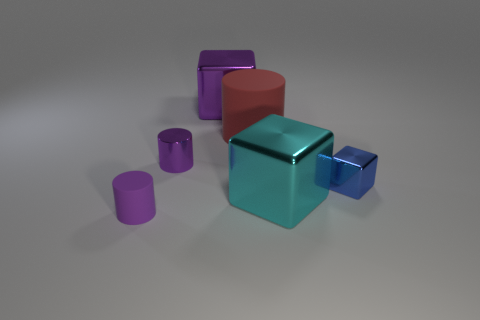There is a cyan metallic thing in front of the big object that is left of the matte cylinder that is on the right side of the big purple thing; what shape is it?
Keep it short and to the point. Cube. What material is the purple object that is both behind the cyan metal cube and in front of the big purple shiny object?
Keep it short and to the point. Metal. What number of purple cylinders are the same size as the blue object?
Keep it short and to the point. 2. What number of shiny things are either small red balls or cyan cubes?
Provide a short and direct response. 1. What is the large purple block made of?
Offer a terse response. Metal. What number of small purple objects are to the right of the red rubber thing?
Offer a terse response. 0. Is the material of the large block to the left of the large red rubber thing the same as the cyan object?
Your answer should be compact. Yes. What number of other purple shiny things are the same shape as the large purple object?
Ensure brevity in your answer.  0. What number of large objects are cubes or yellow cylinders?
Ensure brevity in your answer.  2. There is a big metallic object that is behind the large matte object; does it have the same color as the large cylinder?
Your answer should be very brief. No. 